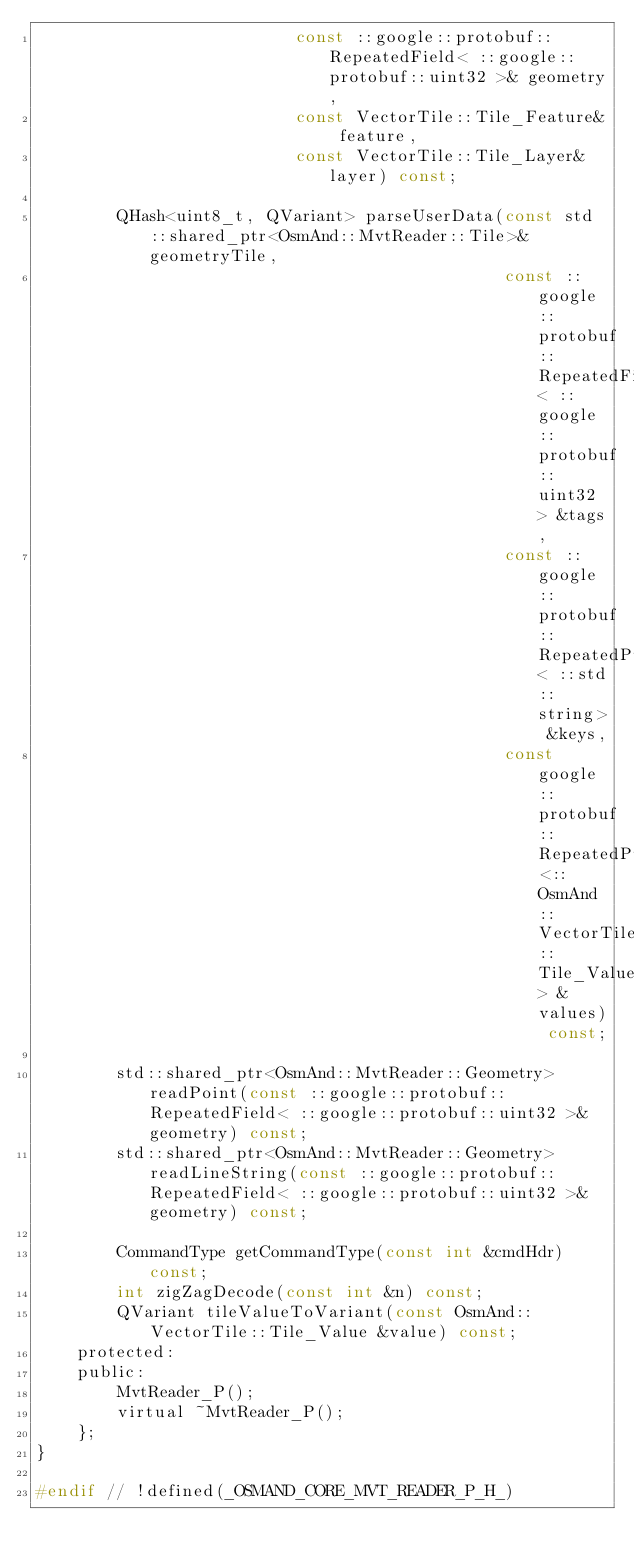<code> <loc_0><loc_0><loc_500><loc_500><_C_>                          const ::google::protobuf::RepeatedField< ::google::protobuf::uint32 >& geometry,
                          const VectorTile::Tile_Feature& feature,
                          const VectorTile::Tile_Layer& layer) const;
        
        QHash<uint8_t, QVariant> parseUserData(const std::shared_ptr<OsmAnd::MvtReader::Tile>& geometryTile,
                                               const ::google::protobuf::RepeatedField< ::google::protobuf::uint32 > &tags,
                                               const ::google::protobuf::RepeatedPtrField< ::std::string> &keys,
                                               const google::protobuf::RepeatedPtrField<::OsmAnd::VectorTile::Tile_Value> &values) const;
        
        std::shared_ptr<OsmAnd::MvtReader::Geometry> readPoint(const ::google::protobuf::RepeatedField< ::google::protobuf::uint32 >& geometry) const;
        std::shared_ptr<OsmAnd::MvtReader::Geometry> readLineString(const ::google::protobuf::RepeatedField< ::google::protobuf::uint32 >& geometry) const;
        
        CommandType getCommandType(const int &cmdHdr) const;
        int zigZagDecode(const int &n) const;
        QVariant tileValueToVariant(const OsmAnd::VectorTile::Tile_Value &value) const;
    protected:
    public:
        MvtReader_P();
        virtual ~MvtReader_P();
    };
}

#endif // !defined(_OSMAND_CORE_MVT_READER_P_H_)
</code> 